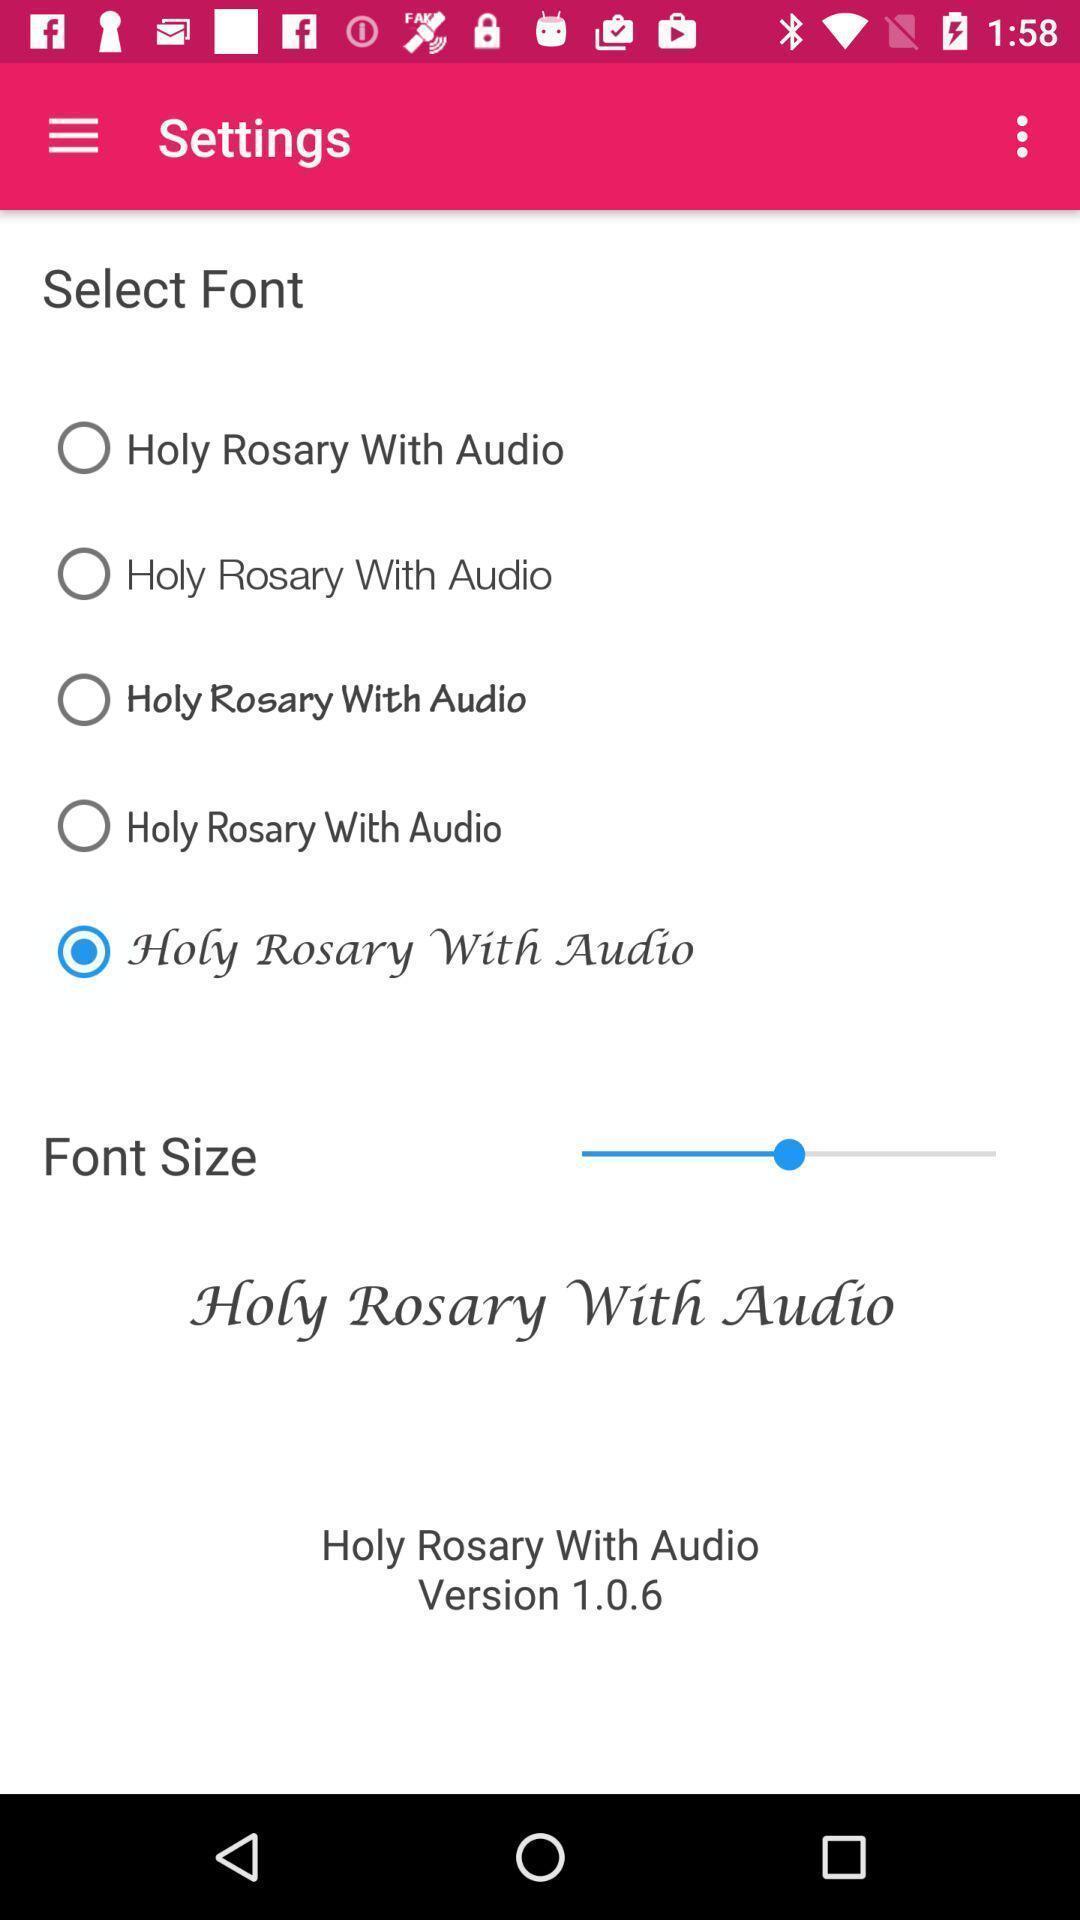Summarize the information in this screenshot. Page showing the options to select in settings. 